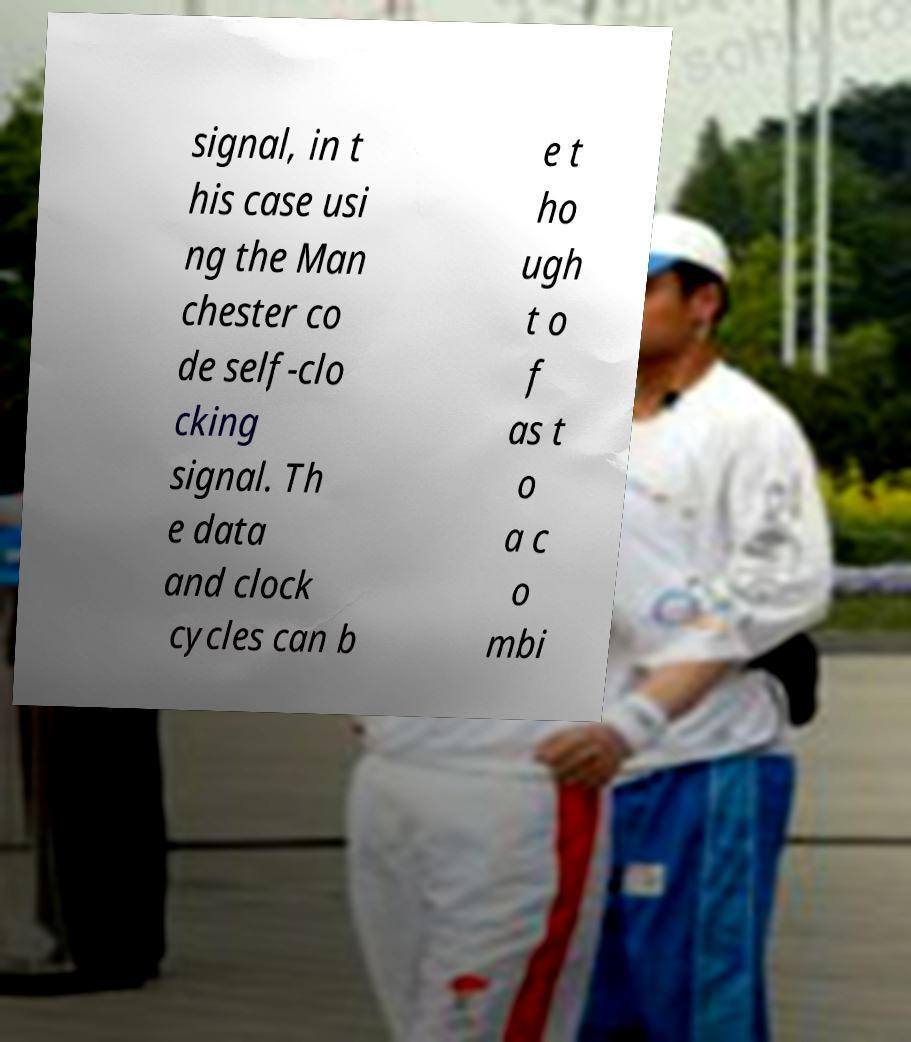Could you extract and type out the text from this image? signal, in t his case usi ng the Man chester co de self-clo cking signal. Th e data and clock cycles can b e t ho ugh t o f as t o a c o mbi 